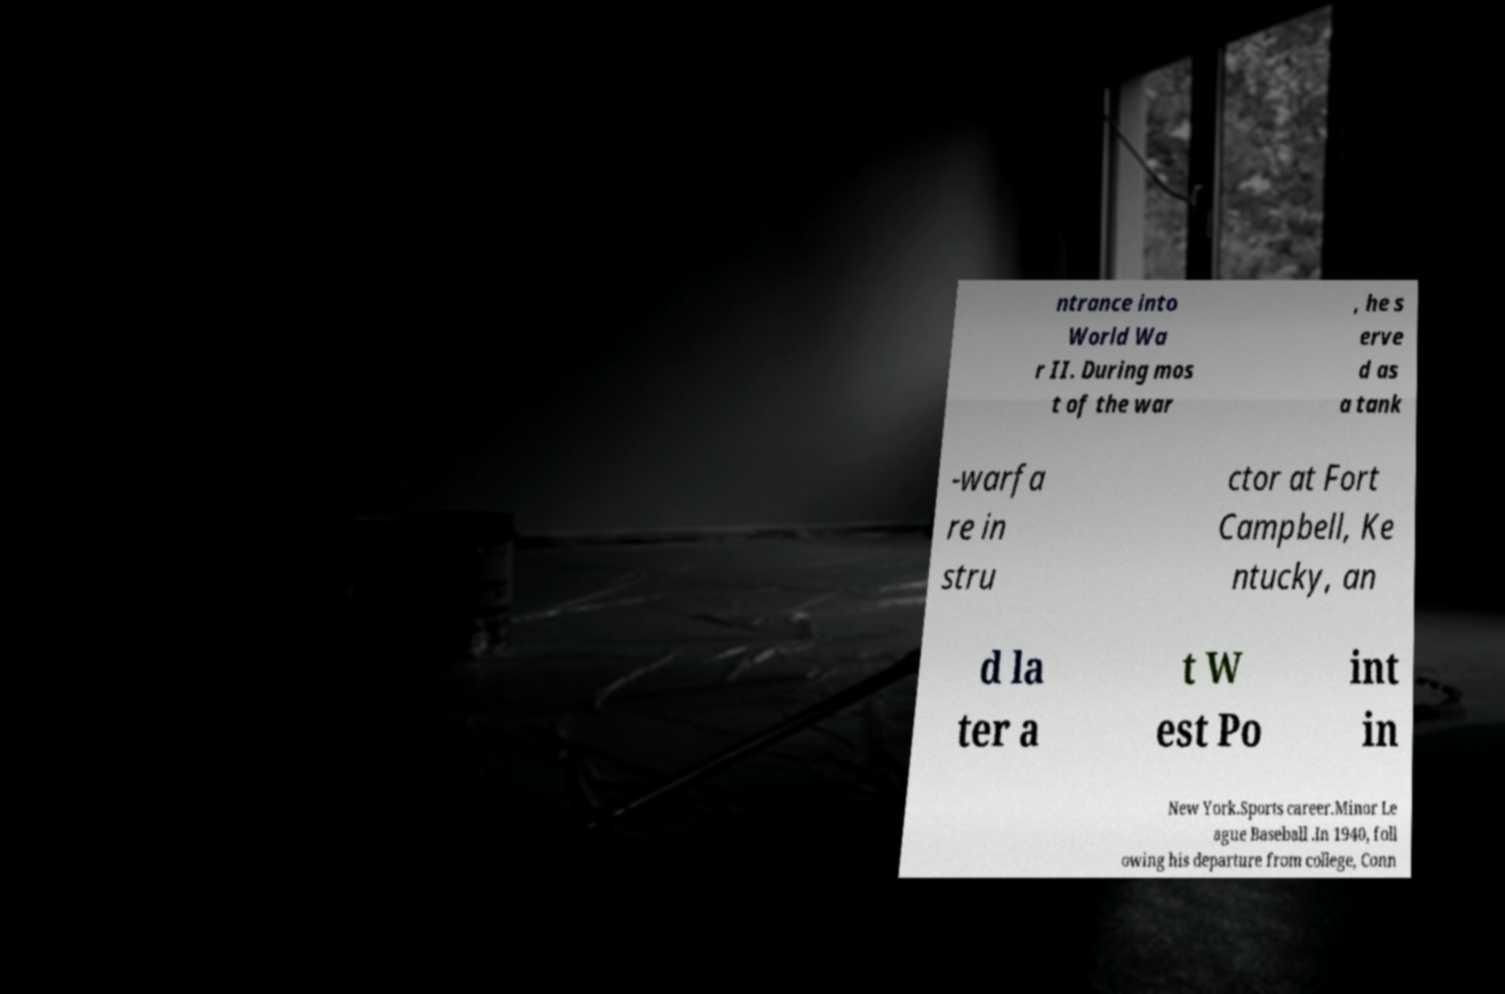Could you extract and type out the text from this image? ntrance into World Wa r II. During mos t of the war , he s erve d as a tank -warfa re in stru ctor at Fort Campbell, Ke ntucky, an d la ter a t W est Po int in New York.Sports career.Minor Le ague Baseball .In 1940, foll owing his departure from college, Conn 